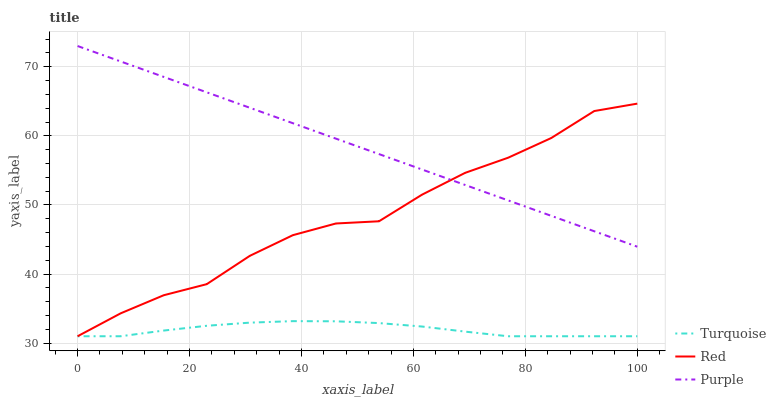Does Turquoise have the minimum area under the curve?
Answer yes or no. Yes. Does Purple have the maximum area under the curve?
Answer yes or no. Yes. Does Red have the minimum area under the curve?
Answer yes or no. No. Does Red have the maximum area under the curve?
Answer yes or no. No. Is Purple the smoothest?
Answer yes or no. Yes. Is Red the roughest?
Answer yes or no. Yes. Is Turquoise the smoothest?
Answer yes or no. No. Is Turquoise the roughest?
Answer yes or no. No. Does Turquoise have the lowest value?
Answer yes or no. Yes. Does Purple have the highest value?
Answer yes or no. Yes. Does Red have the highest value?
Answer yes or no. No. Is Turquoise less than Purple?
Answer yes or no. Yes. Is Purple greater than Turquoise?
Answer yes or no. Yes. Does Red intersect Purple?
Answer yes or no. Yes. Is Red less than Purple?
Answer yes or no. No. Is Red greater than Purple?
Answer yes or no. No. Does Turquoise intersect Purple?
Answer yes or no. No. 